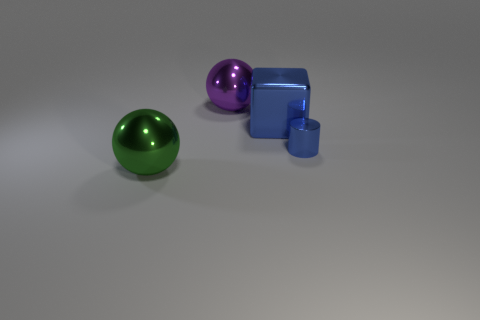Add 4 tiny cyan cylinders. How many objects exist? 8 Subtract all cylinders. How many objects are left? 3 Add 3 small objects. How many small objects are left? 4 Add 1 large green metallic objects. How many large green metallic objects exist? 2 Subtract 1 purple balls. How many objects are left? 3 Subtract all blue things. Subtract all big shiny balls. How many objects are left? 0 